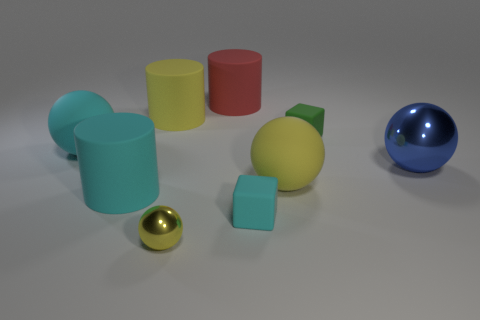Subtract all big metal balls. How many balls are left? 3 Add 1 red things. How many objects exist? 10 Subtract 2 cylinders. How many cylinders are left? 1 Subtract all cylinders. How many objects are left? 6 Subtract all blue balls. How many balls are left? 3 Add 7 tiny balls. How many tiny balls exist? 8 Subtract 1 green blocks. How many objects are left? 8 Subtract all red cylinders. Subtract all brown cubes. How many cylinders are left? 2 Subtract all gray balls. How many red cylinders are left? 1 Subtract all green rubber cubes. Subtract all big yellow balls. How many objects are left? 7 